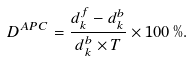Convert formula to latex. <formula><loc_0><loc_0><loc_500><loc_500>D ^ { A P C } = \frac { d _ { k } ^ { f } - d _ { k } ^ { b } } { d _ { k } ^ { b } \times T } \times 1 0 0 \, \% .</formula> 